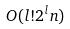<formula> <loc_0><loc_0><loc_500><loc_500>O ( l ! 2 ^ { l } n )</formula> 